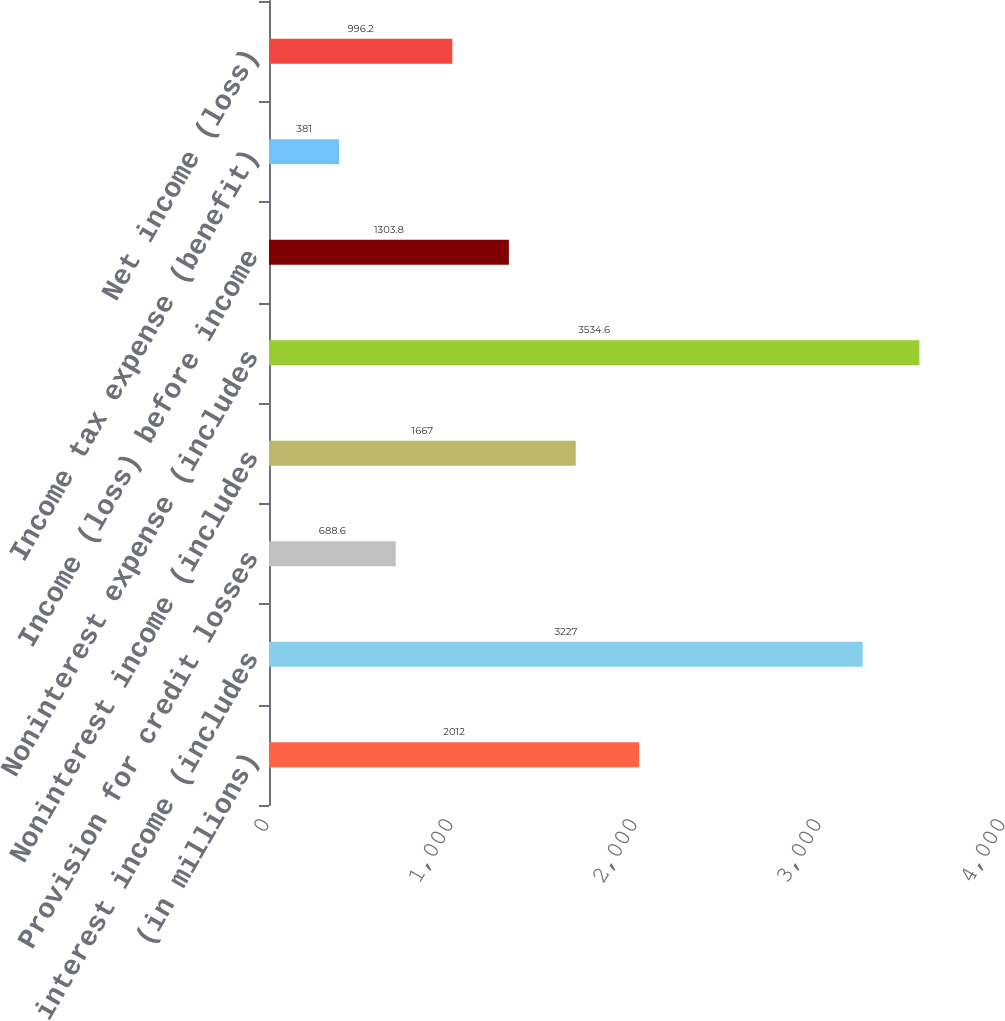Convert chart. <chart><loc_0><loc_0><loc_500><loc_500><bar_chart><fcel>(in millions)<fcel>Net interest income (includes<fcel>Provision for credit losses<fcel>Noninterest income (includes<fcel>Noninterest expense (includes<fcel>Income (loss) before income<fcel>Income tax expense (benefit)<fcel>Net income (loss)<nl><fcel>2012<fcel>3227<fcel>688.6<fcel>1667<fcel>3534.6<fcel>1303.8<fcel>381<fcel>996.2<nl></chart> 